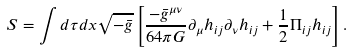Convert formula to latex. <formula><loc_0><loc_0><loc_500><loc_500>S = \int d \tau d { x } \sqrt { - \bar { g } } \left [ \frac { - \bar { g } ^ { \mu \nu } } { 6 4 \pi G } \partial _ { \mu } h _ { i j } \partial _ { \nu } h _ { i j } + \frac { 1 } { 2 } \Pi _ { i j } h _ { i j } \right ] .</formula> 